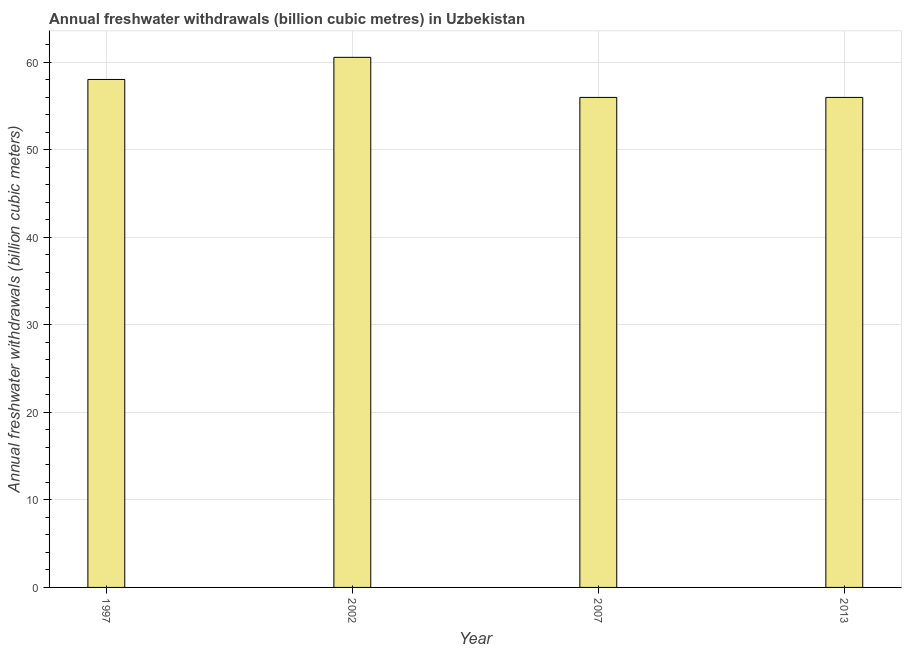Does the graph contain grids?
Keep it short and to the point. Yes. What is the title of the graph?
Offer a very short reply. Annual freshwater withdrawals (billion cubic metres) in Uzbekistan. What is the label or title of the X-axis?
Your answer should be very brief. Year. What is the label or title of the Y-axis?
Keep it short and to the point. Annual freshwater withdrawals (billion cubic meters). What is the annual freshwater withdrawals in 2002?
Your answer should be compact. 60.58. Across all years, what is the maximum annual freshwater withdrawals?
Offer a very short reply. 60.58. Across all years, what is the minimum annual freshwater withdrawals?
Your answer should be compact. 56. In which year was the annual freshwater withdrawals minimum?
Make the answer very short. 2007. What is the sum of the annual freshwater withdrawals?
Make the answer very short. 230.63. What is the difference between the annual freshwater withdrawals in 1997 and 2013?
Your response must be concise. 2.05. What is the average annual freshwater withdrawals per year?
Provide a succinct answer. 57.66. What is the median annual freshwater withdrawals?
Your answer should be very brief. 57.02. What is the ratio of the annual freshwater withdrawals in 2002 to that in 2007?
Offer a very short reply. 1.08. Is the annual freshwater withdrawals in 2002 less than that in 2013?
Make the answer very short. No. What is the difference between the highest and the second highest annual freshwater withdrawals?
Your answer should be compact. 2.53. Is the sum of the annual freshwater withdrawals in 2002 and 2013 greater than the maximum annual freshwater withdrawals across all years?
Your answer should be compact. Yes. What is the difference between the highest and the lowest annual freshwater withdrawals?
Offer a very short reply. 4.58. In how many years, is the annual freshwater withdrawals greater than the average annual freshwater withdrawals taken over all years?
Your answer should be very brief. 2. How many bars are there?
Your response must be concise. 4. Are all the bars in the graph horizontal?
Make the answer very short. No. How many years are there in the graph?
Give a very brief answer. 4. What is the difference between two consecutive major ticks on the Y-axis?
Give a very brief answer. 10. What is the Annual freshwater withdrawals (billion cubic meters) in 1997?
Provide a succinct answer. 58.05. What is the Annual freshwater withdrawals (billion cubic meters) in 2002?
Offer a terse response. 60.58. What is the difference between the Annual freshwater withdrawals (billion cubic meters) in 1997 and 2002?
Keep it short and to the point. -2.53. What is the difference between the Annual freshwater withdrawals (billion cubic meters) in 1997 and 2007?
Provide a succinct answer. 2.05. What is the difference between the Annual freshwater withdrawals (billion cubic meters) in 1997 and 2013?
Offer a terse response. 2.05. What is the difference between the Annual freshwater withdrawals (billion cubic meters) in 2002 and 2007?
Give a very brief answer. 4.58. What is the difference between the Annual freshwater withdrawals (billion cubic meters) in 2002 and 2013?
Keep it short and to the point. 4.58. What is the ratio of the Annual freshwater withdrawals (billion cubic meters) in 1997 to that in 2002?
Offer a very short reply. 0.96. What is the ratio of the Annual freshwater withdrawals (billion cubic meters) in 2002 to that in 2007?
Offer a terse response. 1.08. What is the ratio of the Annual freshwater withdrawals (billion cubic meters) in 2002 to that in 2013?
Your response must be concise. 1.08. What is the ratio of the Annual freshwater withdrawals (billion cubic meters) in 2007 to that in 2013?
Provide a short and direct response. 1. 